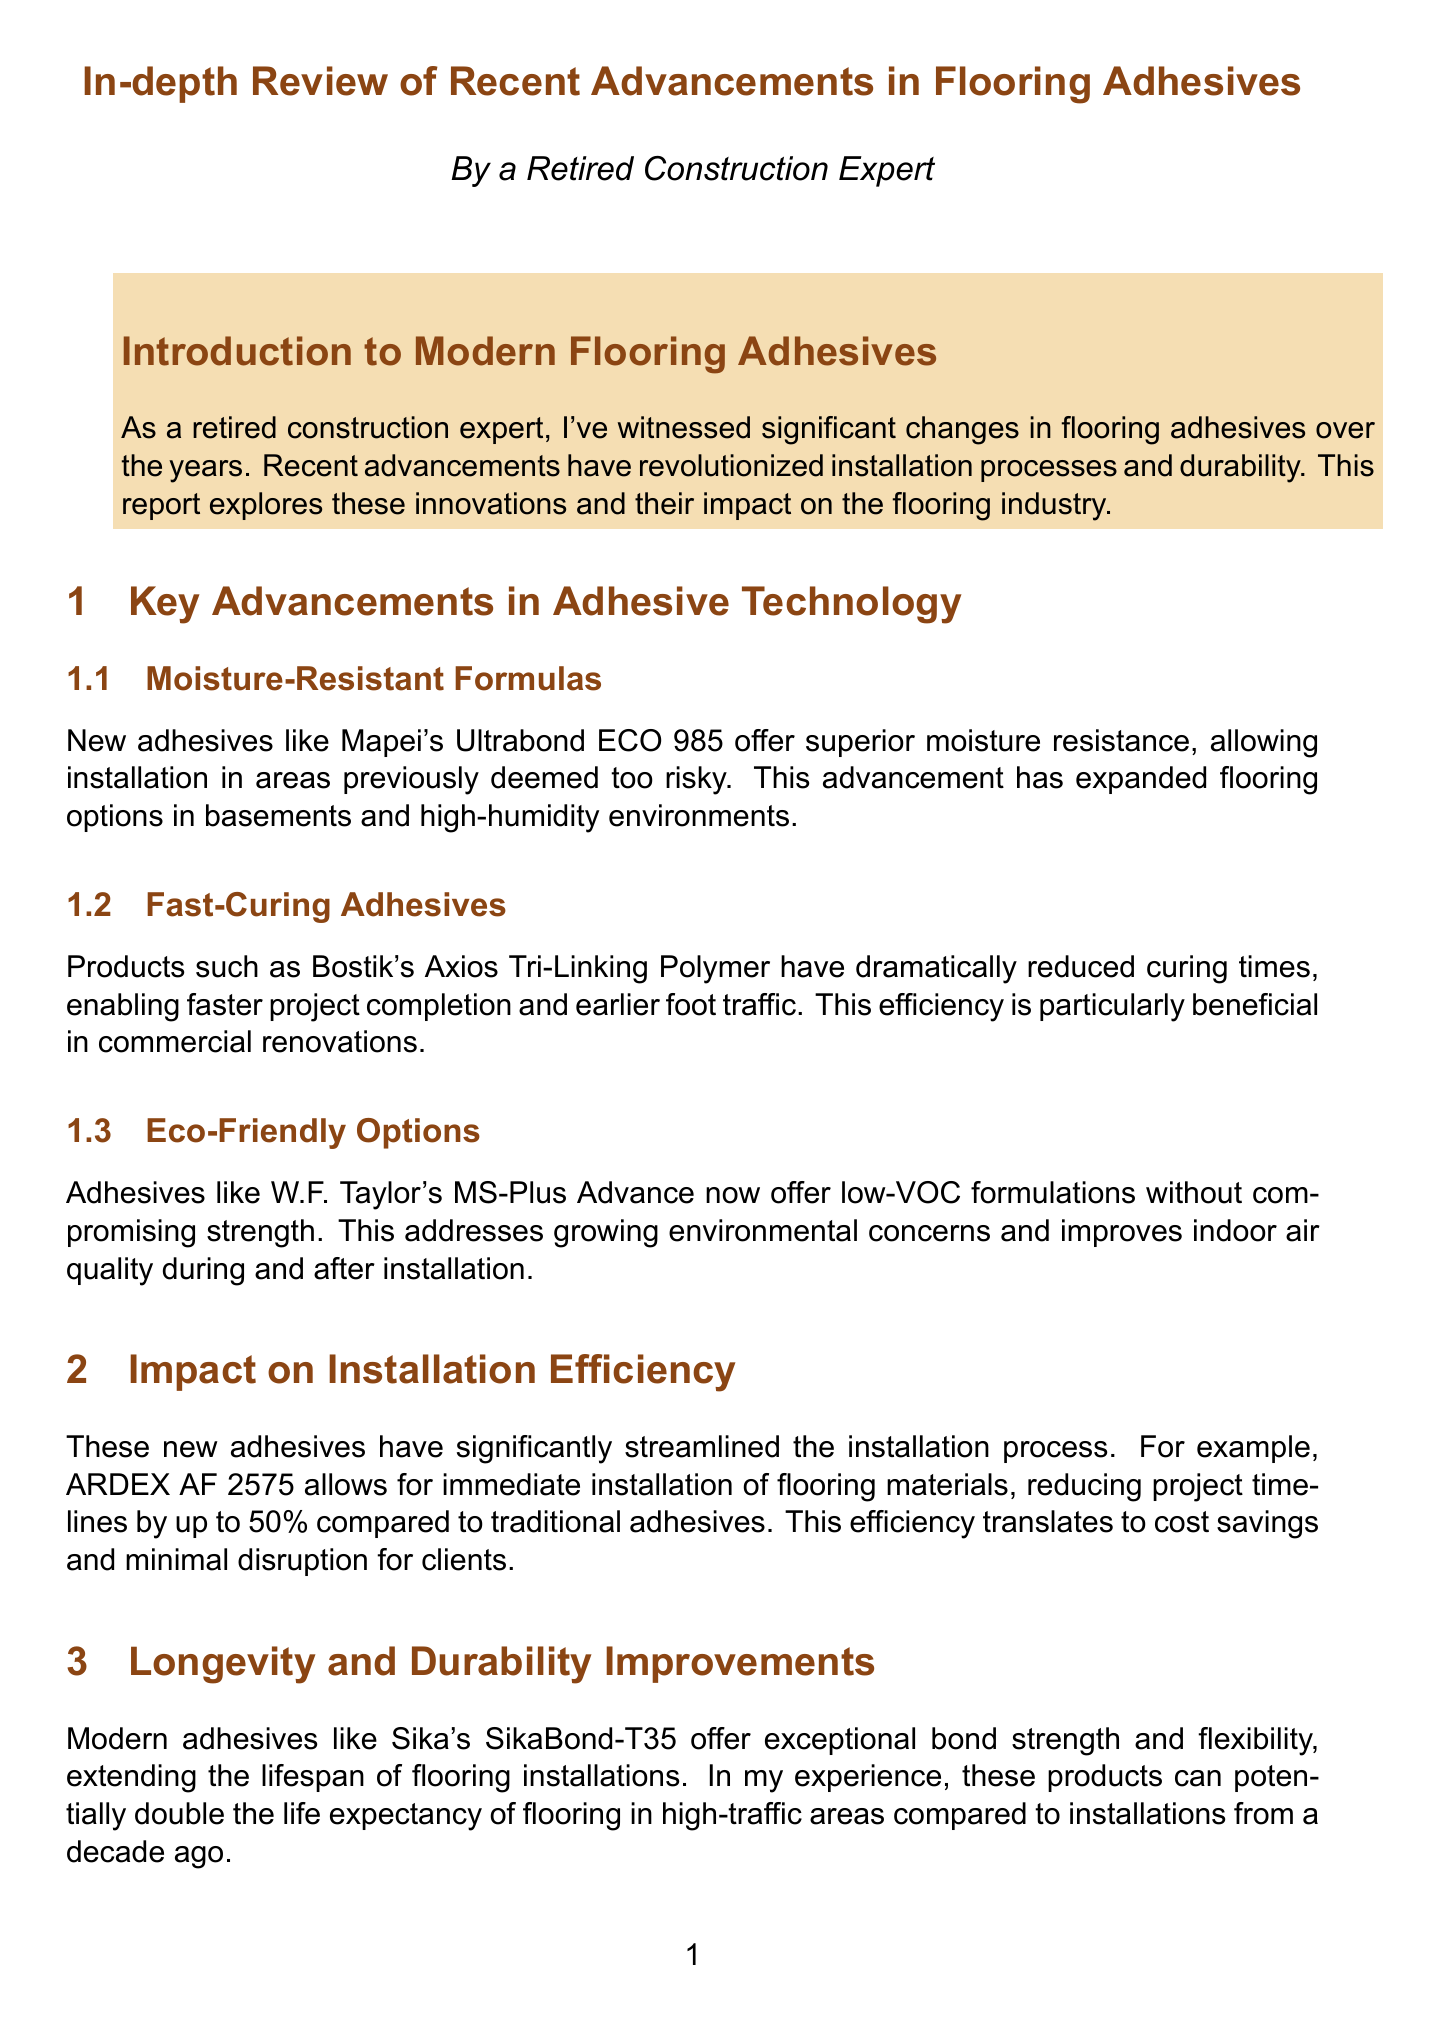What is the name of a moisture-resistant adhesive mentioned? The document lists Mapei's Ultrabond ECO 985 as a moisture-resistant adhesive.
Answer: Mapei's Ultrabond ECO 985 Which adhesive has fast-curing properties? Bostik's Axios Tri-Linking Polymer is identified as a product with fast-curing properties.
Answer: Bostik's Axios Tri-Linking Polymer What percentage reduction in project timelines does ARDEX AF 2575 provide? The document states that ARDEX AF 2575 can reduce project timelines by up to 50 percent.
Answer: 50% What is a key feature of Sika's SikaBond-T35? Sika's SikaBond-T35 is noted for its exceptional bond strength and flexibility.
Answer: Exceptional bond strength and flexibility What construction challenge is highlighted regarding new adhesives? The report emphasizes that installers must be trained in proper application techniques for each new product.
Answer: Updated skills and knowledge What is the projected area of focus for future adhesive innovations? The document mentions self-leveling adhesives for uneven subfloors as a future focus area.
Answer: Self-leveling adhesives In what type of renovation was Schönox's iLINE adhesive used? The report discusses its use in a commercial office renovation in downtown Chicago.
Answer: Commercial office renovation What environmental concern do eco-friendly adhesives address? The eco-friendly options improve indoor air quality during and after installation.
Answer: Indoor air quality 